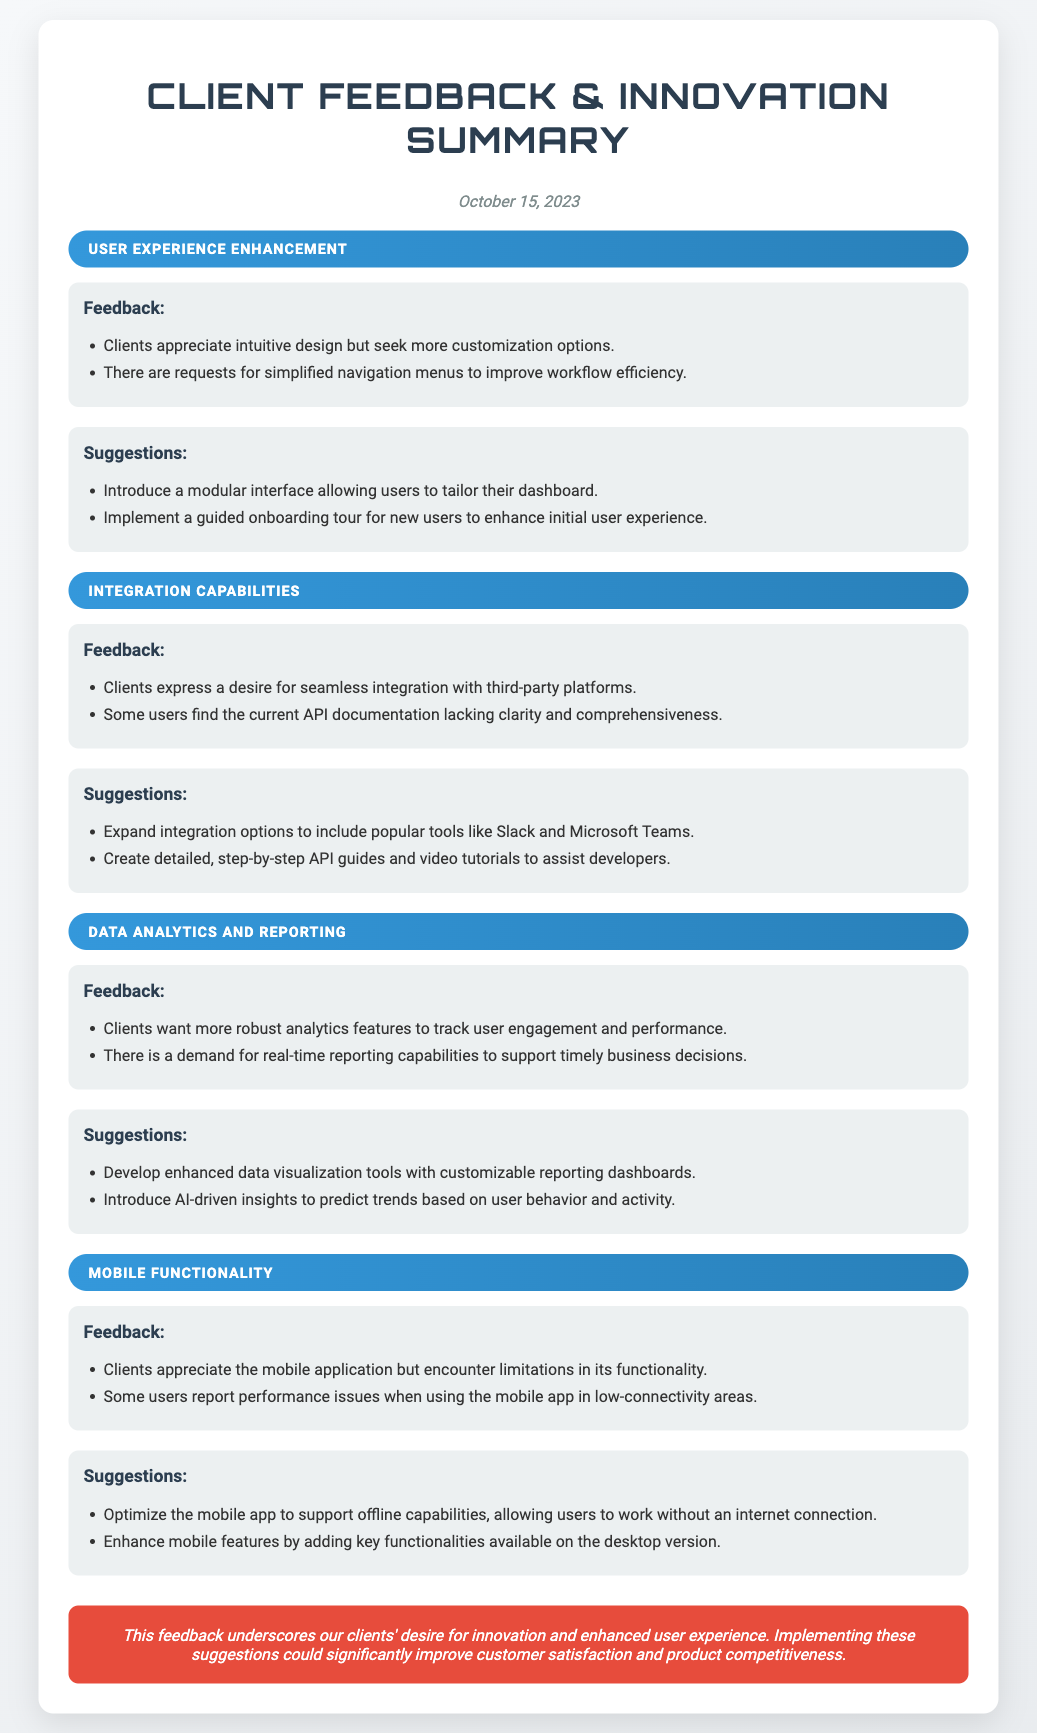what is the date of the summary? The date is clearly indicated at the top of the document, which states "October 15, 2023".
Answer: October 15, 2023 how many themes are discussed in the document? The document lists a total of four distinct themes, each with its own feedback and suggestions sections.
Answer: 4 what is one suggestion for enhancing user experience? One suggestion mentioned is to "Introduce a modular interface allowing users to tailor their dashboard."
Answer: Introduce a modular interface allowing users to tailor their dashboard which third-party platforms do clients want integration with? The document specifies "popular tools like Slack and Microsoft Teams" as desired third-party integrations.
Answer: Slack and Microsoft Teams what is a key demand from clients regarding data analytics? Clients have expressed a desire for "more robust analytics features to track user engagement and performance."
Answer: more robust analytics features to track user engagement and performance what is a feature request for the mobile application? Clients have requested that the mobile app be "optimized to support offline capabilities, allowing users to work without an internet connection."
Answer: optimized to support offline capabilities how does the feedback relate to product competitiveness? The conclusion states that implementing the suggestions could "significantly improve customer satisfaction and product competitiveness."
Answer: significantly improve customer satisfaction and product competitiveness what type of guided support is suggested for new users? The suggestions include implementing "a guided onboarding tour for new users" to improve their initial experience.
Answer: a guided onboarding tour for new users 